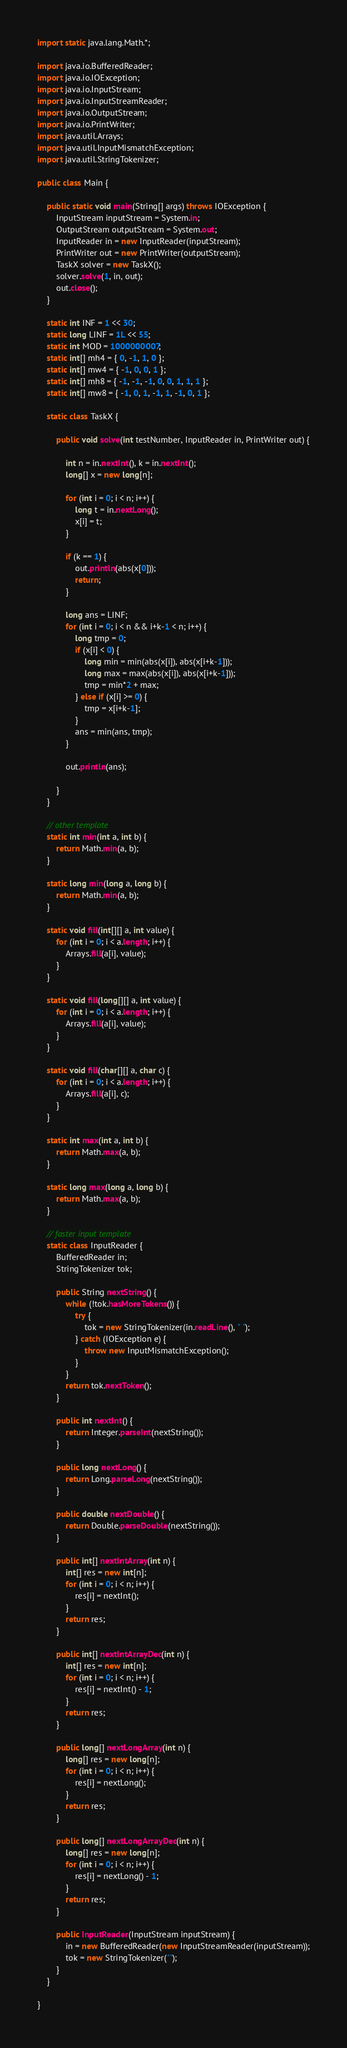<code> <loc_0><loc_0><loc_500><loc_500><_Java_>import static java.lang.Math.*;

import java.io.BufferedReader;
import java.io.IOException;
import java.io.InputStream;
import java.io.InputStreamReader;
import java.io.OutputStream;
import java.io.PrintWriter;
import java.util.Arrays;
import java.util.InputMismatchException;
import java.util.StringTokenizer;

public class Main {

	public static void main(String[] args) throws IOException {
		InputStream inputStream = System.in;
		OutputStream outputStream = System.out;
		InputReader in = new InputReader(inputStream);
		PrintWriter out = new PrintWriter(outputStream);
		TaskX solver = new TaskX();
		solver.solve(1, in, out);
		out.close();
	}

	static int INF = 1 << 30;
	static long LINF = 1L << 55;
	static int MOD = 1000000007;
	static int[] mh4 = { 0, -1, 1, 0 };
	static int[] mw4 = { -1, 0, 0, 1 };
	static int[] mh8 = { -1, -1, -1, 0, 0, 1, 1, 1 };
	static int[] mw8 = { -1, 0, 1, -1, 1, -1, 0, 1 };

	static class TaskX {

		public void solve(int testNumber, InputReader in, PrintWriter out) {

			int n = in.nextInt(), k = in.nextInt();
			long[] x = new long[n];

			for (int i = 0; i < n; i++) {
				long t = in.nextLong();
				x[i] = t;
			}

			if (k == 1) {
				out.println(abs(x[0]));
				return;
			}

			long ans = LINF;
			for (int i = 0; i < n && i+k-1 < n; i++) {
				long tmp = 0;
				if (x[i] < 0) {
					long min = min(abs(x[i]), abs(x[i+k-1]));
					long max = max(abs(x[i]), abs(x[i+k-1]));
					tmp = min*2 + max;
				} else if (x[i] >= 0) {
					tmp = x[i+k-1];
				}
				ans = min(ans, tmp);
			}

			out.println(ans);

		}
	}

	// other template
	static int min(int a, int b) {
		return Math.min(a, b);
	}

	static long min(long a, long b) {
		return Math.min(a, b);
	}

	static void fill(int[][] a, int value) {
		for (int i = 0; i < a.length; i++) {
			Arrays.fill(a[i], value);
		}
	}

	static void fill(long[][] a, int value) {
		for (int i = 0; i < a.length; i++) {
			Arrays.fill(a[i], value);
		}
	}

	static void fill(char[][] a, char c) {
		for (int i = 0; i < a.length; i++) {
			Arrays.fill(a[i], c);
		}
	}

	static int max(int a, int b) {
		return Math.max(a, b);
	}

	static long max(long a, long b) {
		return Math.max(a, b);
	}

	// faster input template
	static class InputReader {
		BufferedReader in;
		StringTokenizer tok;

		public String nextString() {
			while (!tok.hasMoreTokens()) {
				try {
					tok = new StringTokenizer(in.readLine(), " ");
				} catch (IOException e) {
					throw new InputMismatchException();
				}
			}
			return tok.nextToken();
		}

		public int nextInt() {
			return Integer.parseInt(nextString());
		}

		public long nextLong() {
			return Long.parseLong(nextString());
		}

		public double nextDouble() {
			return Double.parseDouble(nextString());
		}

		public int[] nextIntArray(int n) {
			int[] res = new int[n];
			for (int i = 0; i < n; i++) {
				res[i] = nextInt();
			}
			return res;
		}

		public int[] nextIntArrayDec(int n) {
			int[] res = new int[n];
			for (int i = 0; i < n; i++) {
				res[i] = nextInt() - 1;
			}
			return res;
		}

		public long[] nextLongArray(int n) {
			long[] res = new long[n];
			for (int i = 0; i < n; i++) {
				res[i] = nextLong();
			}
			return res;
		}

		public long[] nextLongArrayDec(int n) {
			long[] res = new long[n];
			for (int i = 0; i < n; i++) {
				res[i] = nextLong() - 1;
			}
			return res;
		}

		public InputReader(InputStream inputStream) {
			in = new BufferedReader(new InputStreamReader(inputStream));
			tok = new StringTokenizer("");
		}
	}

}
</code> 